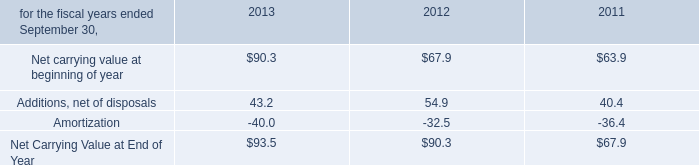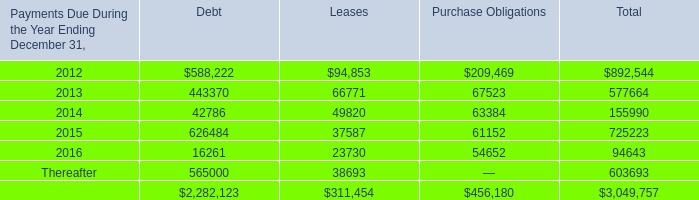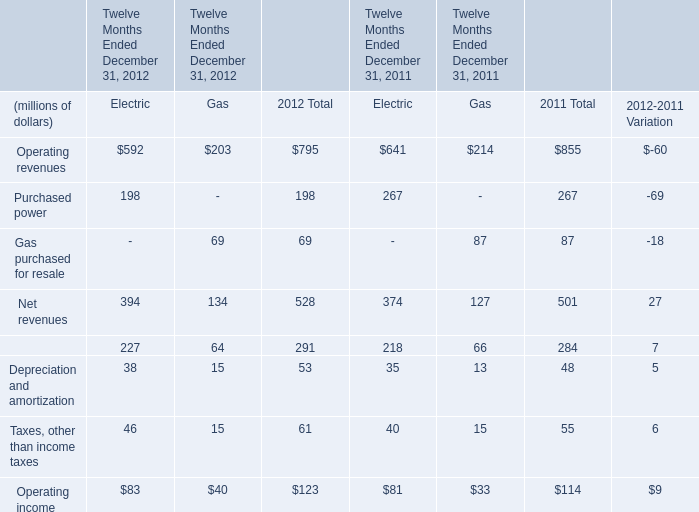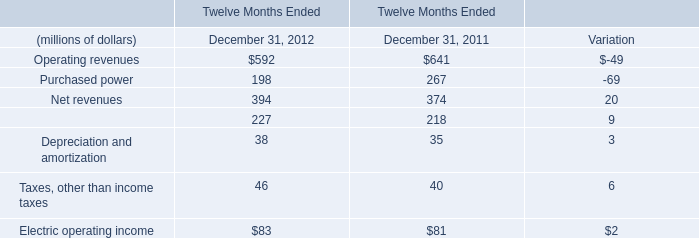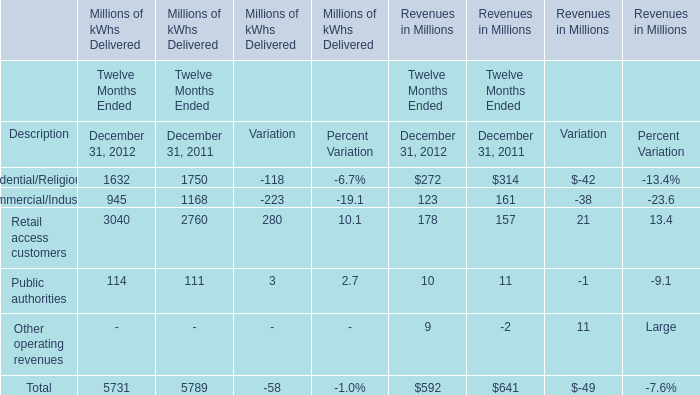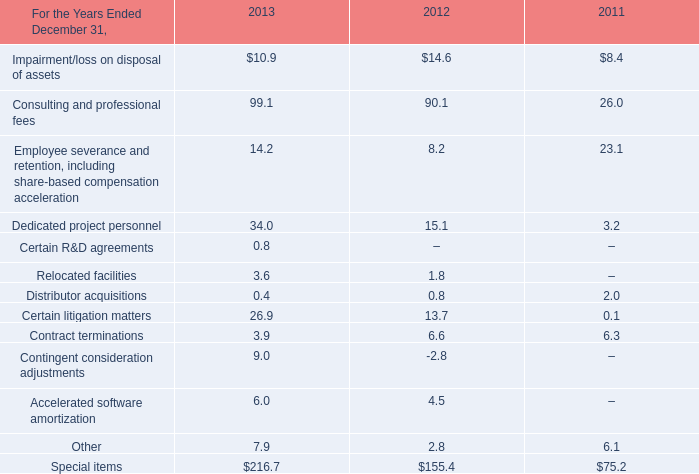What is the growing rate of Additions, net of disposals in Table 0 in the years with the least Gas purchased for resale of Gas in Table 2? 
Computations: ((54.9 - 40.4) / 40.4)
Answer: 0.35891. 